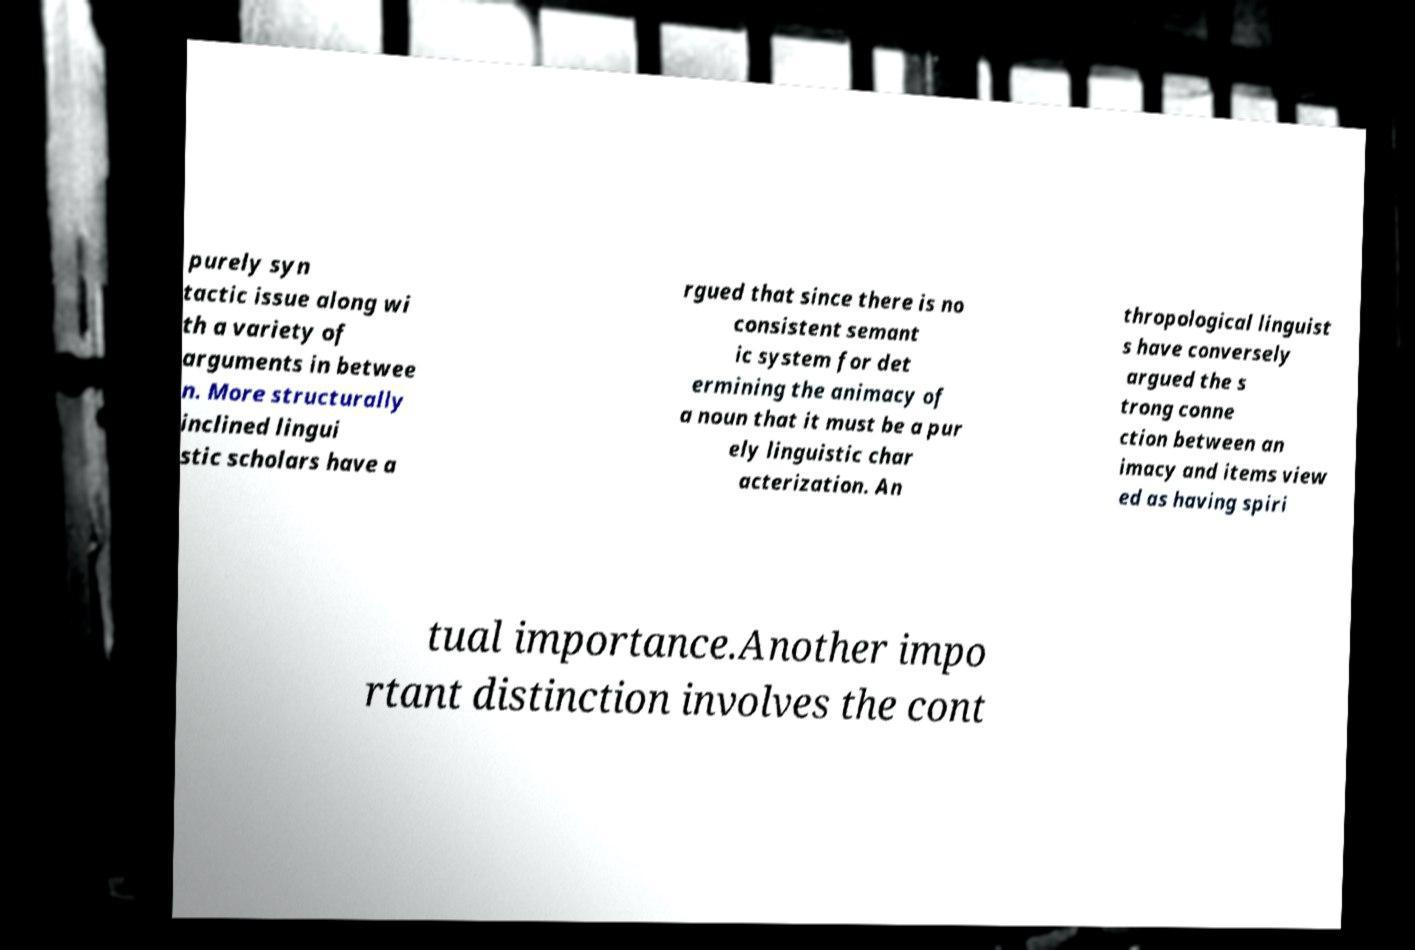Could you extract and type out the text from this image? purely syn tactic issue along wi th a variety of arguments in betwee n. More structurally inclined lingui stic scholars have a rgued that since there is no consistent semant ic system for det ermining the animacy of a noun that it must be a pur ely linguistic char acterization. An thropological linguist s have conversely argued the s trong conne ction between an imacy and items view ed as having spiri tual importance.Another impo rtant distinction involves the cont 